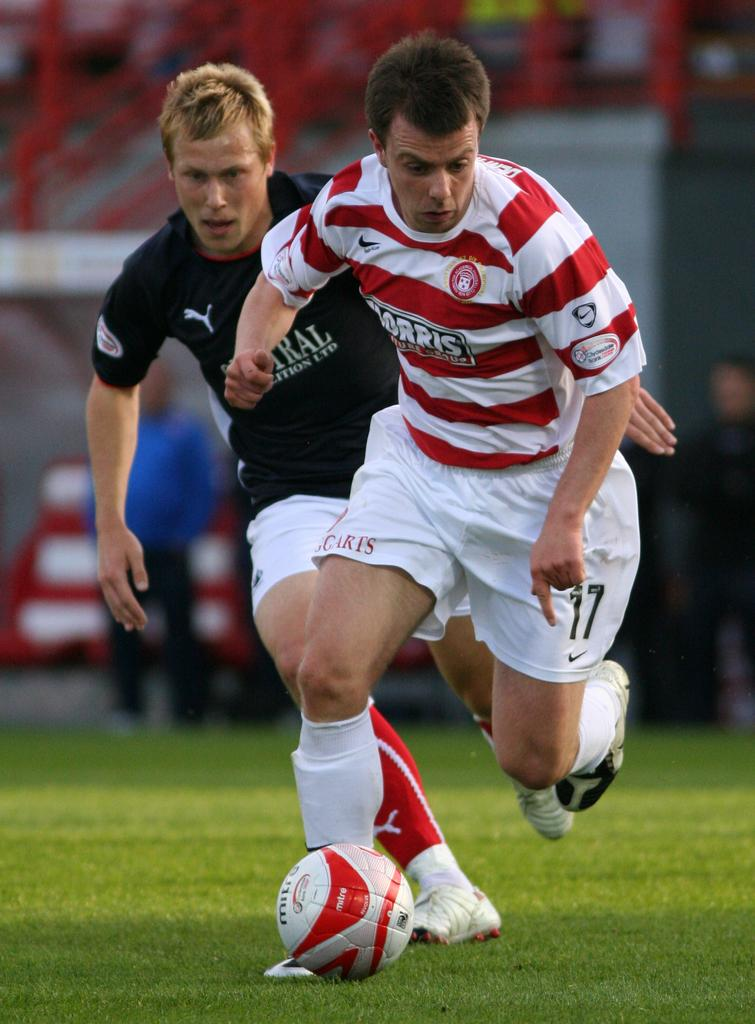How many players are in the image? There are two players in the image. What sport are the players engaged in? The players are playing football. What action are the players performing with the ball? The players are kicking the ball. What type of surface is visible at the bottom of the image? There is a ground at the bottom of the image. What background feature can be seen behind the players? There is a stadium at the back side of the image. Can you see a giraffe in the image? No, there is no giraffe present in the image. What type of pen is being used by the players to write their names on the ball? There is no pen visible in the image, and the players are not writing on the ball; they are kicking it. 